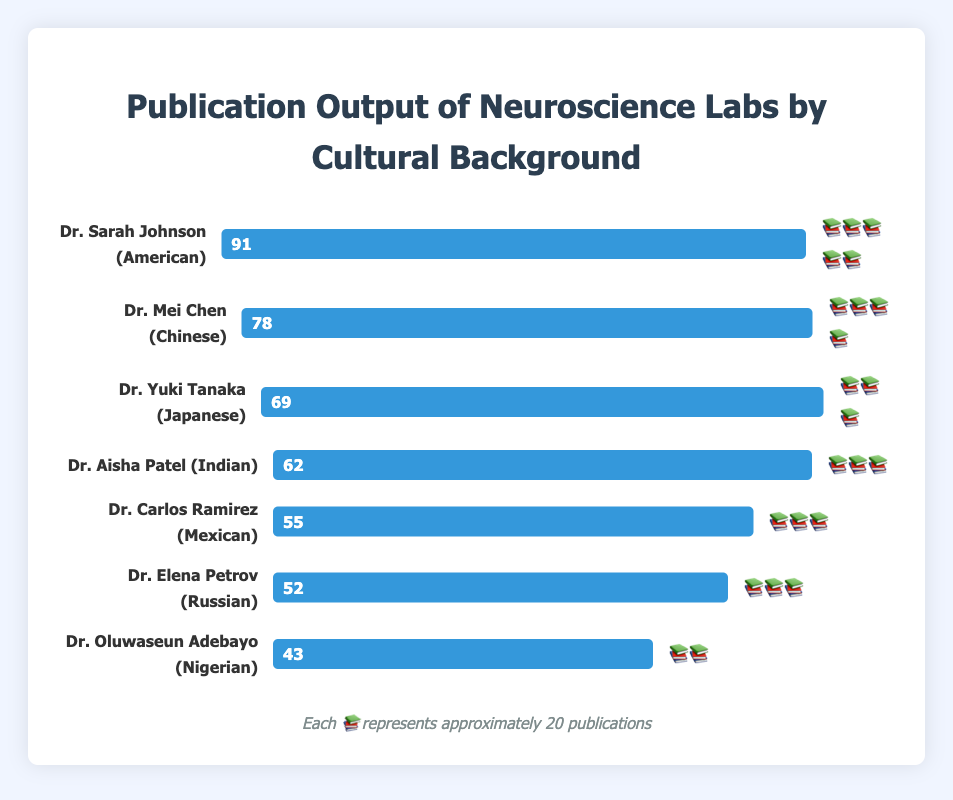what's the total number of data points in the figure? Count the number of bars displayed in the chart. There are seven bars, each representing a different lab lead.
Answer: 7 who has the highest number of publications? Compare the publication numbers for each researcher. Dr. Sarah Johnson has the highest with 91 publications.
Answer: Dr. Sarah Johnson how many publications does Dr. Mei Chen have? Look at the bar labeled "Dr. Mei Chen" and note the number beside it, which is 78.
Answer: 78 which researchers have 3📚 emojis? Identify the researchers associated with three 📚 emojis: Dr. Aisha Patel, Dr. Carlos Ramirez, Dr. Yuki Tanaka, and Dr. Elena Petrov.
Answer: Dr. Aisha Patel, Dr. Carlos Ramirez, Dr. Yuki Tanaka, Dr. Elena Petrov what's the combined publication output of Dr. Aisha Patel and Dr. Yuki Tanaka? Sum the number of publications for Dr. Aisha Patel (62) and Dr. Yuki Tanaka (69). The total is 62 + 69 = 131.
Answer: 131 how many publications does each 📚 emoji approximately represent? According to the legend, each 📚 represents approximately 20 publications.
Answer: approximately 20 who has the lowest number of publications? Compare the publication numbers for each researcher. Dr. Oluwaseun Adebayo has the lowest with 43 publications.
Answer: Dr. Oluwaseun Adebayo how many more publications does Dr. Sarah Johnson have compared to Dr. Carlos Ramirez? Subtract the number of publications of Dr. Carlos Ramirez (55) from that of Dr. Sarah Johnson (91). The difference is 91 - 55 = 36.
Answer: 36 what's the median number of publications among all researchers? List the publication numbers in order: 43, 52, 55, 62, 69, 78, 91. With 7 data points, the median is the fourth number in this ordered list, which is 62.
Answer: 62 